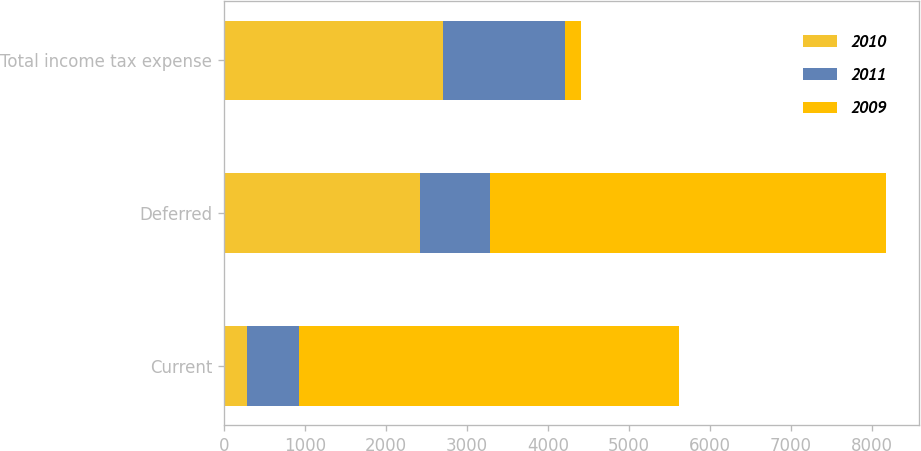<chart> <loc_0><loc_0><loc_500><loc_500><stacked_bar_chart><ecel><fcel>Current<fcel>Deferred<fcel>Total income tax expense<nl><fcel>2010<fcel>283<fcel>2422<fcel>2705<nl><fcel>2011<fcel>639<fcel>860<fcel>1499<nl><fcel>2009<fcel>4692<fcel>4894<fcel>202<nl></chart> 